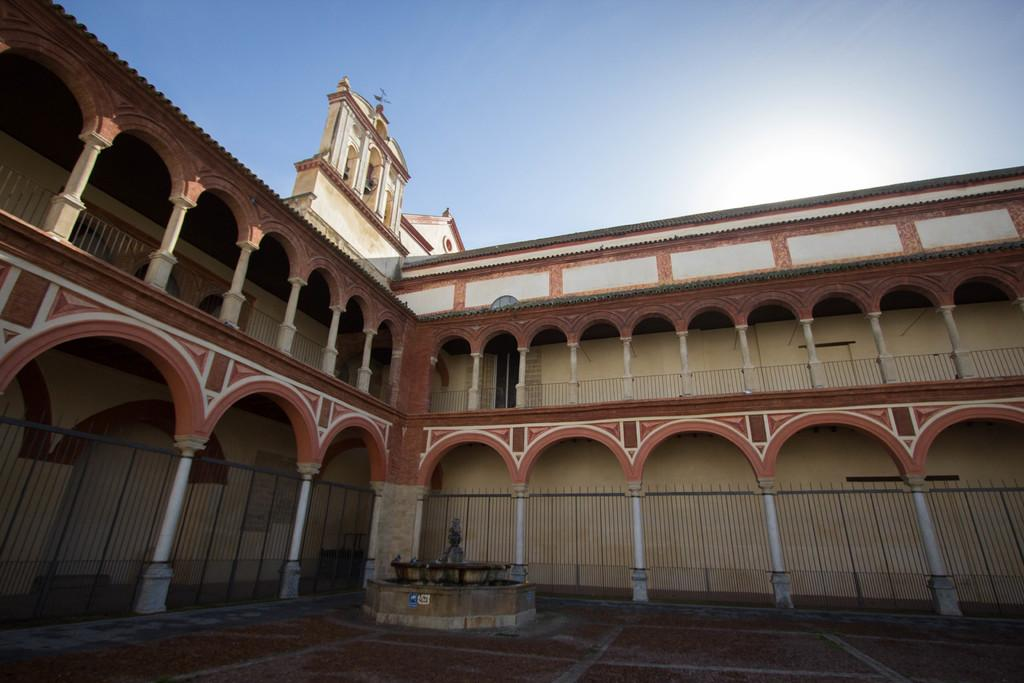What can be seen at the bottom of the image? The ground is visible in the image. What type of structure is present in the image? There is metal railing in the image. What colors are used to paint the building in the image? The building is brown, cream, and white in color. What is visible in the background of the image? The sky is visible in the background of the image. Can you see any boats in the harbor in the image? There is no harbor or boats present in the image. What type of cord is used to hold the bath in place in the image? There is no bath or cord present in the image. 